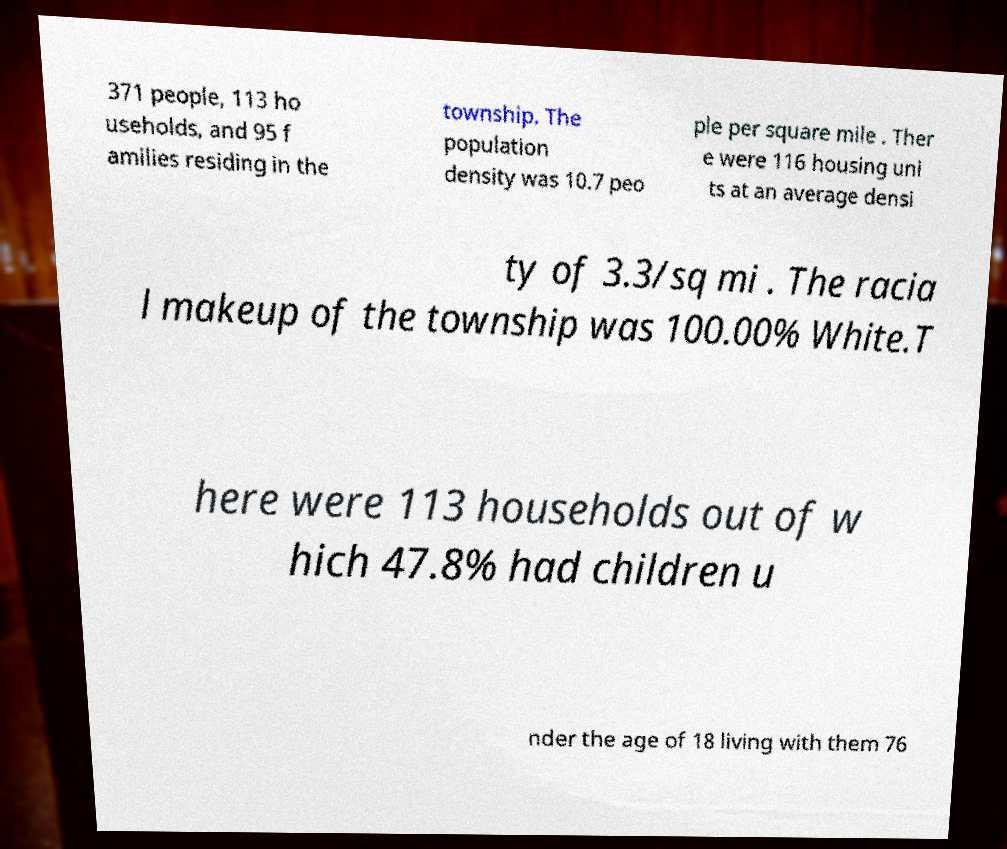There's text embedded in this image that I need extracted. Can you transcribe it verbatim? 371 people, 113 ho useholds, and 95 f amilies residing in the township. The population density was 10.7 peo ple per square mile . Ther e were 116 housing uni ts at an average densi ty of 3.3/sq mi . The racia l makeup of the township was 100.00% White.T here were 113 households out of w hich 47.8% had children u nder the age of 18 living with them 76 